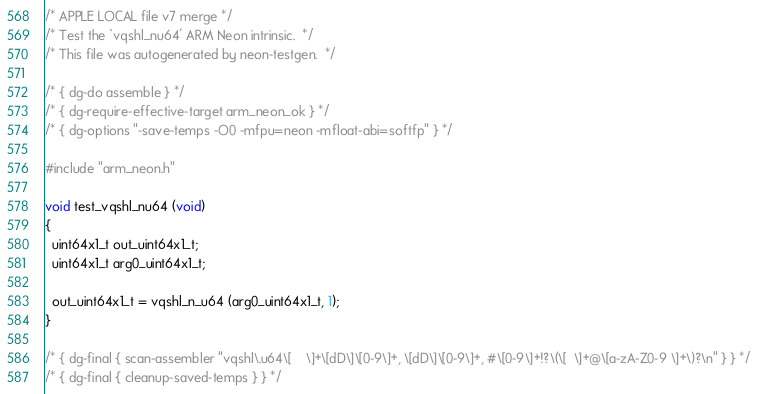Convert code to text. <code><loc_0><loc_0><loc_500><loc_500><_C_>/* APPLE LOCAL file v7 merge */
/* Test the `vqshl_nu64' ARM Neon intrinsic.  */
/* This file was autogenerated by neon-testgen.  */

/* { dg-do assemble } */
/* { dg-require-effective-target arm_neon_ok } */
/* { dg-options "-save-temps -O0 -mfpu=neon -mfloat-abi=softfp" } */

#include "arm_neon.h"

void test_vqshl_nu64 (void)
{
  uint64x1_t out_uint64x1_t;
  uint64x1_t arg0_uint64x1_t;

  out_uint64x1_t = vqshl_n_u64 (arg0_uint64x1_t, 1);
}

/* { dg-final { scan-assembler "vqshl\.u64\[ 	\]+\[dD\]\[0-9\]+, \[dD\]\[0-9\]+, #\[0-9\]+!?\(\[ 	\]+@\[a-zA-Z0-9 \]+\)?\n" } } */
/* { dg-final { cleanup-saved-temps } } */
</code> 